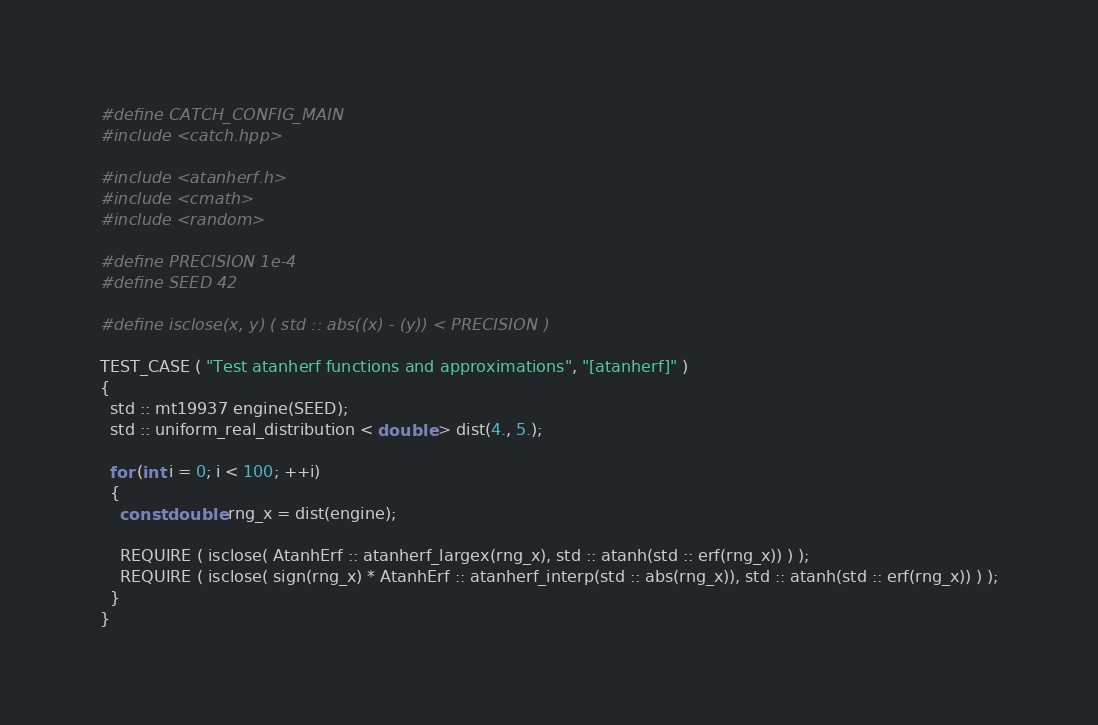<code> <loc_0><loc_0><loc_500><loc_500><_C++_>#define CATCH_CONFIG_MAIN
#include <catch.hpp>

#include <atanherf.h>
#include <cmath>
#include <random>

#define PRECISION 1e-4
#define SEED 42

#define isclose(x, y) ( std :: abs((x) - (y)) < PRECISION )

TEST_CASE ( "Test atanherf functions and approximations", "[atanherf]" )
{
  std :: mt19937 engine(SEED);
  std :: uniform_real_distribution < double > dist(4., 5.);

  for (int i = 0; i < 100; ++i)
  {
    const double rng_x = dist(engine);

    REQUIRE ( isclose( AtanhErf :: atanherf_largex(rng_x), std :: atanh(std :: erf(rng_x)) ) );
    REQUIRE ( isclose( sign(rng_x) * AtanhErf :: atanherf_interp(std :: abs(rng_x)), std :: atanh(std :: erf(rng_x)) ) );
  }
}

</code> 